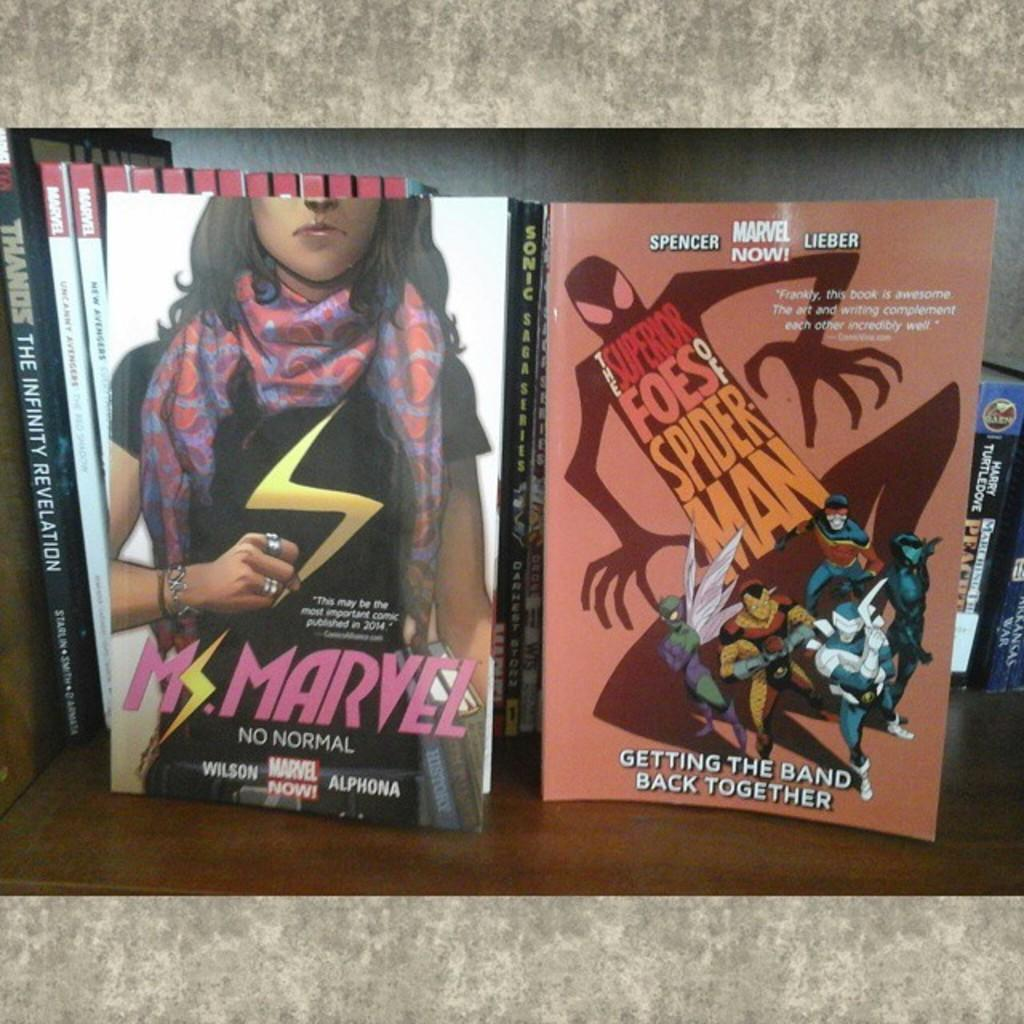<image>
Summarize the visual content of the image. two books right next to one another with the word 'marvel' on both of them 